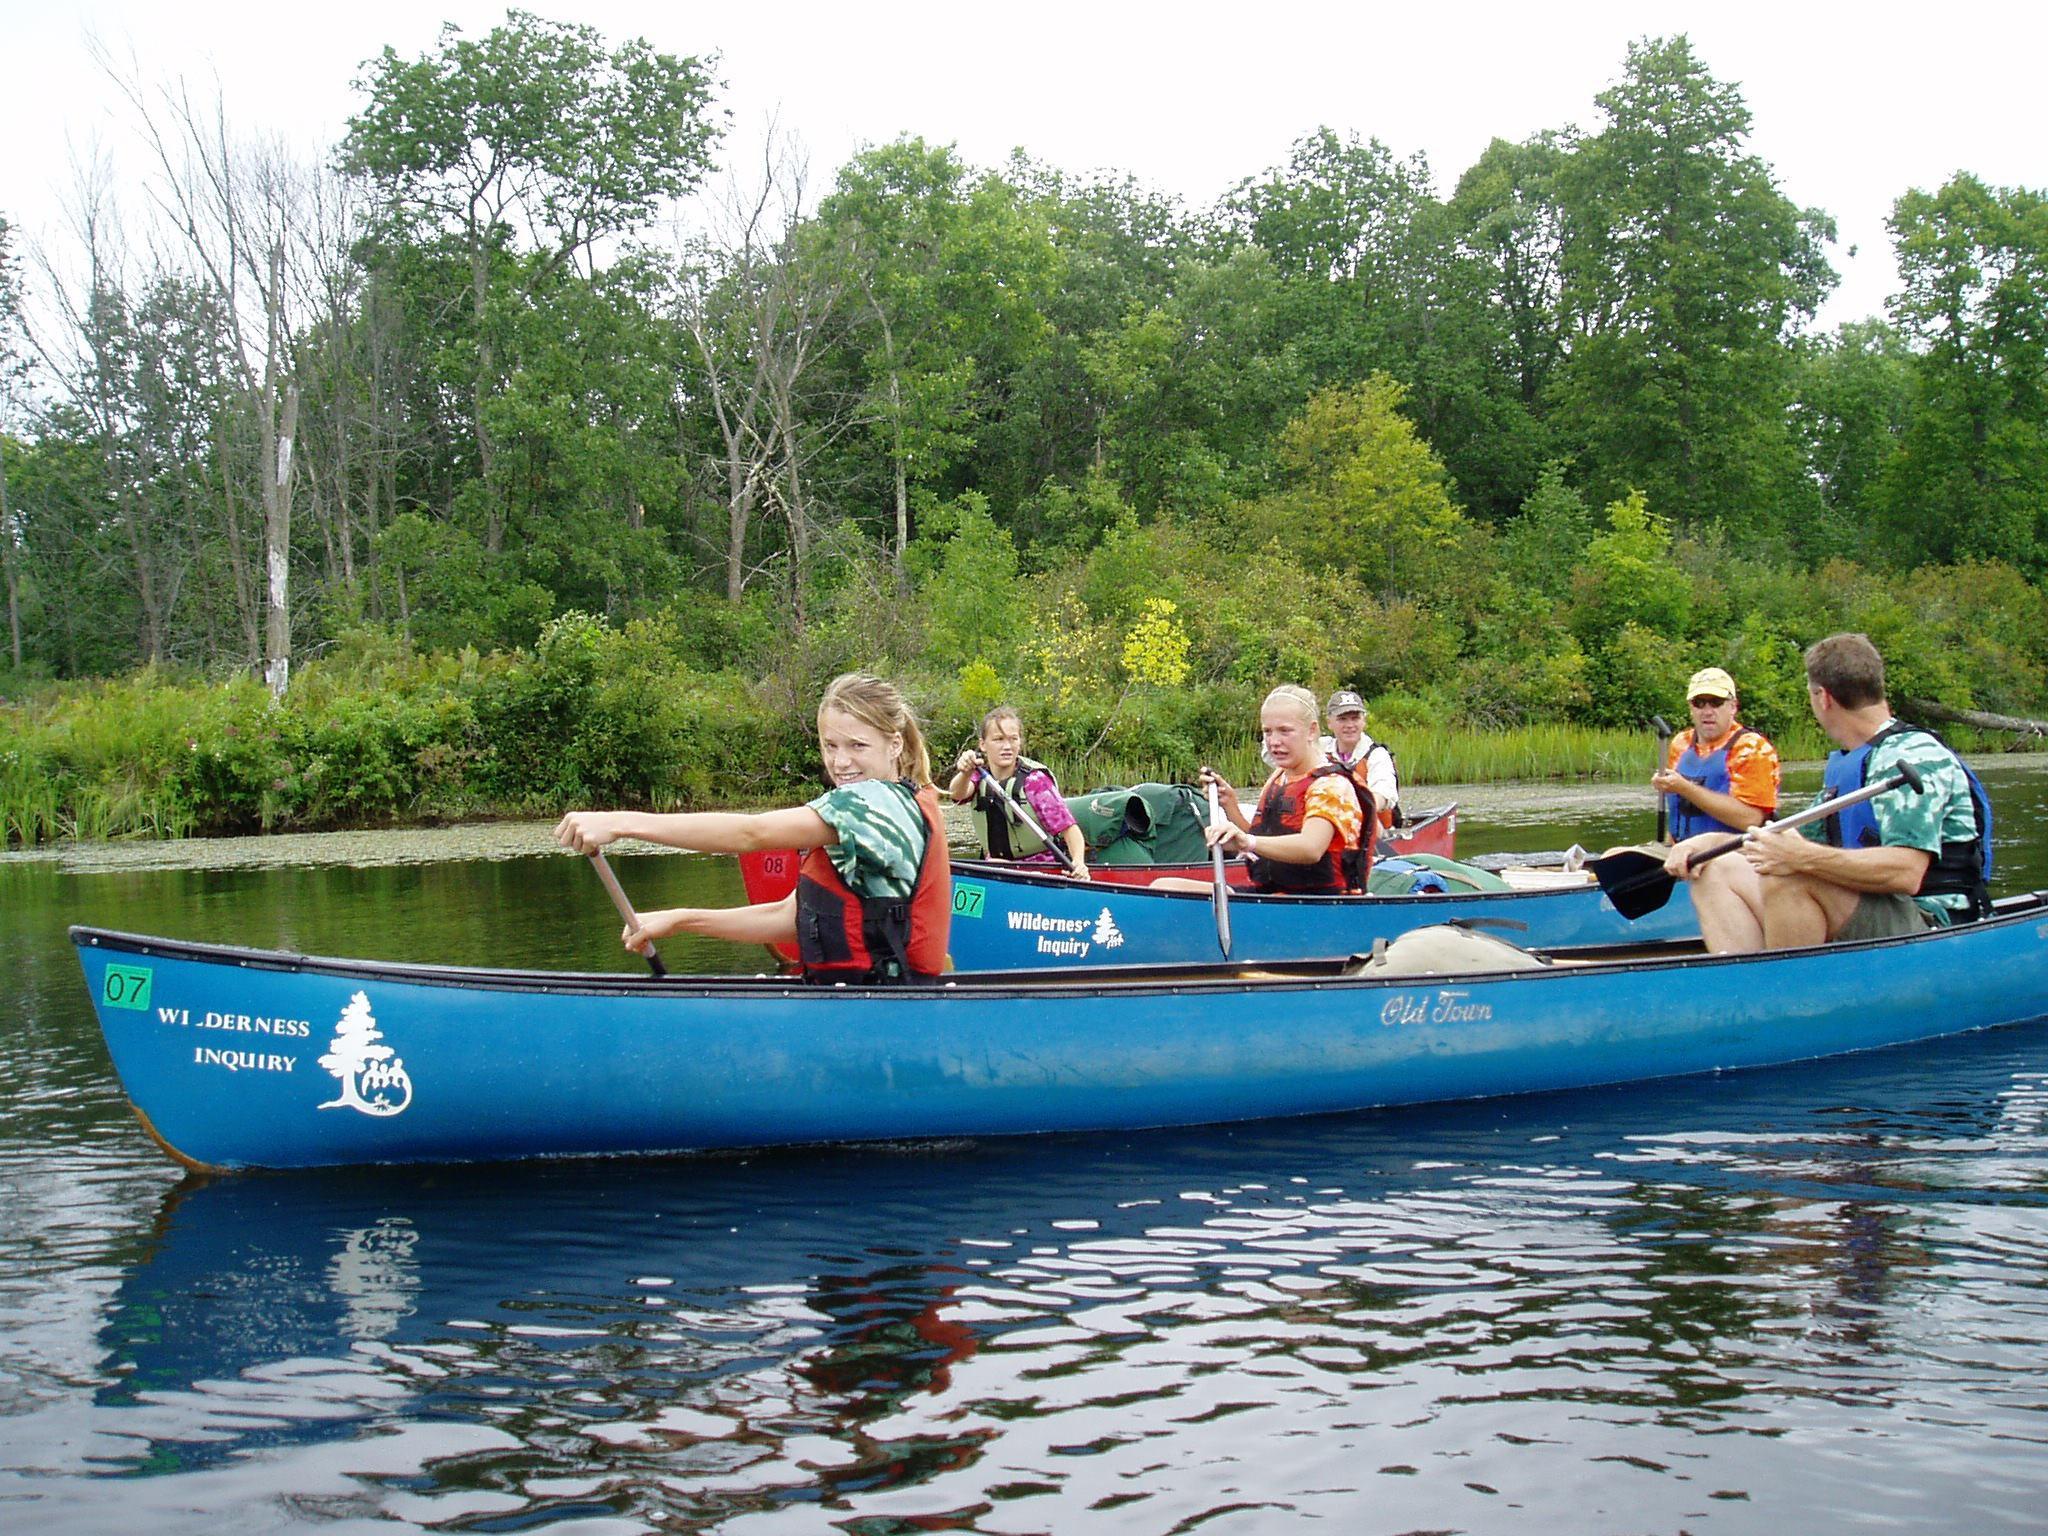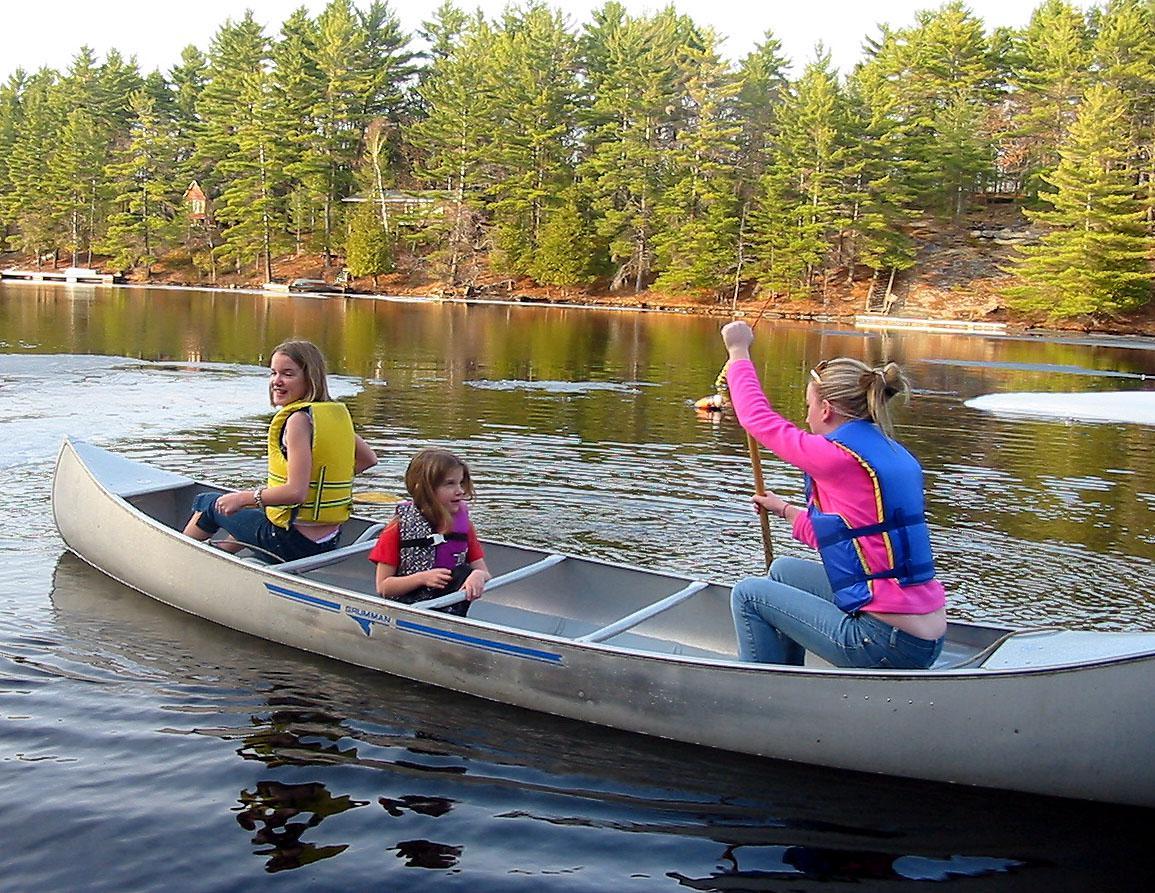The first image is the image on the left, the second image is the image on the right. Given the left and right images, does the statement "Three adults paddle a single canoe though the water in the image on the right." hold true? Answer yes or no. No. The first image is the image on the left, the second image is the image on the right. For the images shown, is this caption "Three people ride a red canoe horizontally across the right image." true? Answer yes or no. No. 